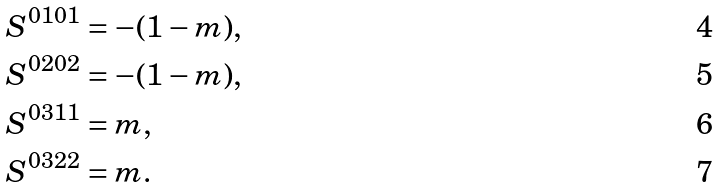Convert formula to latex. <formula><loc_0><loc_0><loc_500><loc_500>S ^ { 0 1 0 1 } & = - ( 1 - m ) , \\ S ^ { 0 2 0 2 } & = - ( 1 - m ) , \\ S ^ { 0 3 1 1 } & = m , \\ S ^ { 0 3 2 2 } & = m .</formula> 